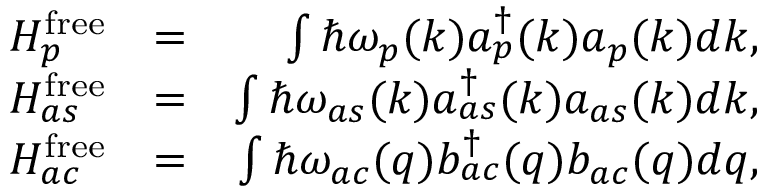<formula> <loc_0><loc_0><loc_500><loc_500>\begin{array} { r l r } { H _ { p } ^ { f r e e } } & { = } & { \int \hbar { \omega } _ { p } ( k ) a _ { p } ^ { \dagger } ( k ) a _ { p } ( k ) d k , } \\ { H _ { a s } ^ { f r e e } } & { = } & { \int \hbar { \omega } _ { a s } ( k ) a _ { a s } ^ { \dagger } ( k ) a _ { a s } ( k ) d k , } \\ { H _ { a c } ^ { f r e e } } & { = } & { \int \hbar { \omega } _ { a c } ( q ) b _ { a c } ^ { \dagger } ( q ) b _ { a c } ( q ) d q , } \end{array}</formula> 